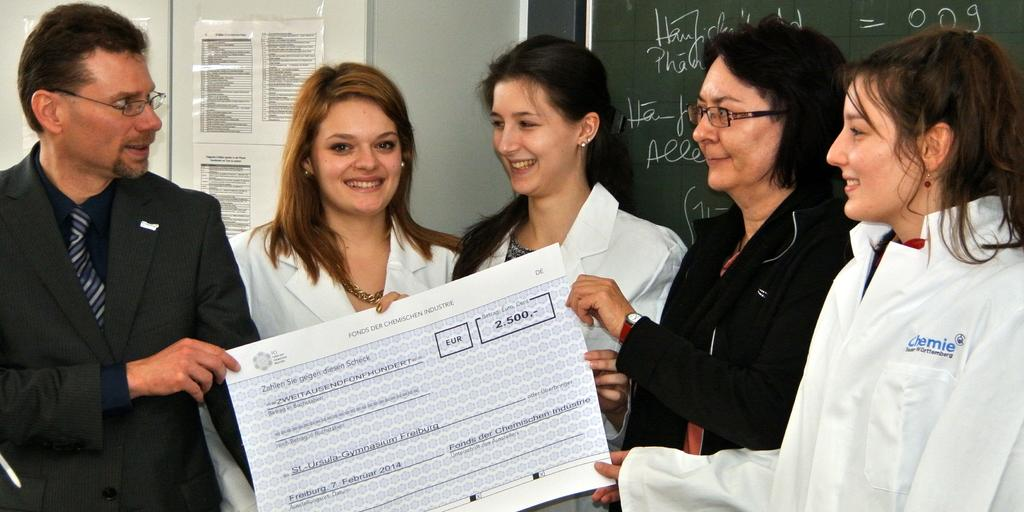How many people are in the image? There is a group of people in the image, but the exact number is not specified. What are some people doing in the image? Some people are holding an object, but the nature of the object is not mentioned. What can be seen on the notice board in the image? There are papers on a notice board in the image. What is written on the board in the image? There is text written on a board in the image. Can you describe the flock of birds flying along the coast in the image? There is no flock of birds or coastline visible in the image. 